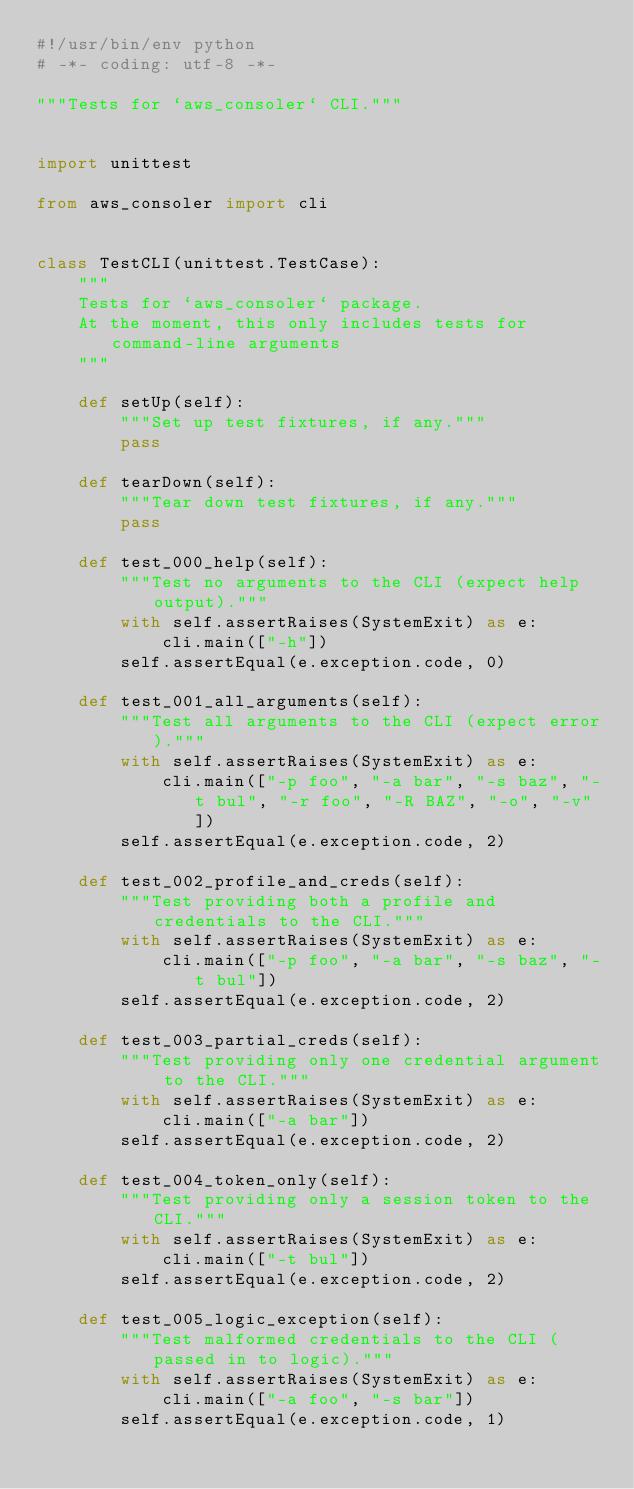<code> <loc_0><loc_0><loc_500><loc_500><_Python_>#!/usr/bin/env python
# -*- coding: utf-8 -*-

"""Tests for `aws_consoler` CLI."""


import unittest

from aws_consoler import cli


class TestCLI(unittest.TestCase):
    """
    Tests for `aws_consoler` package.
    At the moment, this only includes tests for command-line arguments
    """

    def setUp(self):
        """Set up test fixtures, if any."""
        pass

    def tearDown(self):
        """Tear down test fixtures, if any."""
        pass

    def test_000_help(self):
        """Test no arguments to the CLI (expect help output)."""
        with self.assertRaises(SystemExit) as e:
            cli.main(["-h"])
        self.assertEqual(e.exception.code, 0)

    def test_001_all_arguments(self):
        """Test all arguments to the CLI (expect error)."""
        with self.assertRaises(SystemExit) as e:
            cli.main(["-p foo", "-a bar", "-s baz", "-t bul", "-r foo", "-R BAZ", "-o", "-v"])
        self.assertEqual(e.exception.code, 2)

    def test_002_profile_and_creds(self):
        """Test providing both a profile and credentials to the CLI."""
        with self.assertRaises(SystemExit) as e:
            cli.main(["-p foo", "-a bar", "-s baz", "-t bul"])
        self.assertEqual(e.exception.code, 2)

    def test_003_partial_creds(self):
        """Test providing only one credential argument to the CLI."""
        with self.assertRaises(SystemExit) as e:
            cli.main(["-a bar"])
        self.assertEqual(e.exception.code, 2)

    def test_004_token_only(self):
        """Test providing only a session token to the CLI."""
        with self.assertRaises(SystemExit) as e:
            cli.main(["-t bul"])
        self.assertEqual(e.exception.code, 2)

    def test_005_logic_exception(self):
        """Test malformed credentials to the CLI (passed in to logic)."""
        with self.assertRaises(SystemExit) as e:
            cli.main(["-a foo", "-s bar"])
        self.assertEqual(e.exception.code, 1)

</code> 